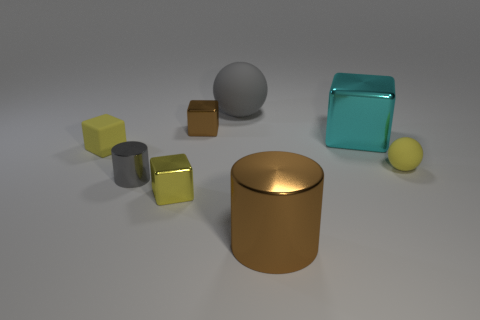There is a brown thing that is behind the brown metallic thing that is in front of the block that is right of the big gray ball; what is it made of?
Your response must be concise. Metal. How many other objects are there of the same size as the yellow shiny cube?
Make the answer very short. 4. Is the tiny matte ball the same color as the large matte object?
Provide a short and direct response. No. There is a small shiny object that is behind the small matte object on the right side of the matte block; how many blocks are to the right of it?
Provide a succinct answer. 1. The gray object behind the small matte thing that is on the right side of the large gray sphere is made of what material?
Give a very brief answer. Rubber. Are there any other metal things that have the same shape as the big cyan object?
Ensure brevity in your answer.  Yes. What color is the matte thing that is the same size as the yellow rubber block?
Your answer should be very brief. Yellow. What number of objects are either tiny blocks that are in front of the big cyan metallic cube or cylinders on the right side of the tiny cylinder?
Offer a very short reply. 3. What number of objects are either tiny red metal cylinders or tiny spheres?
Offer a terse response. 1. How big is the yellow object that is to the left of the large cyan cube and in front of the small rubber block?
Your answer should be compact. Small. 